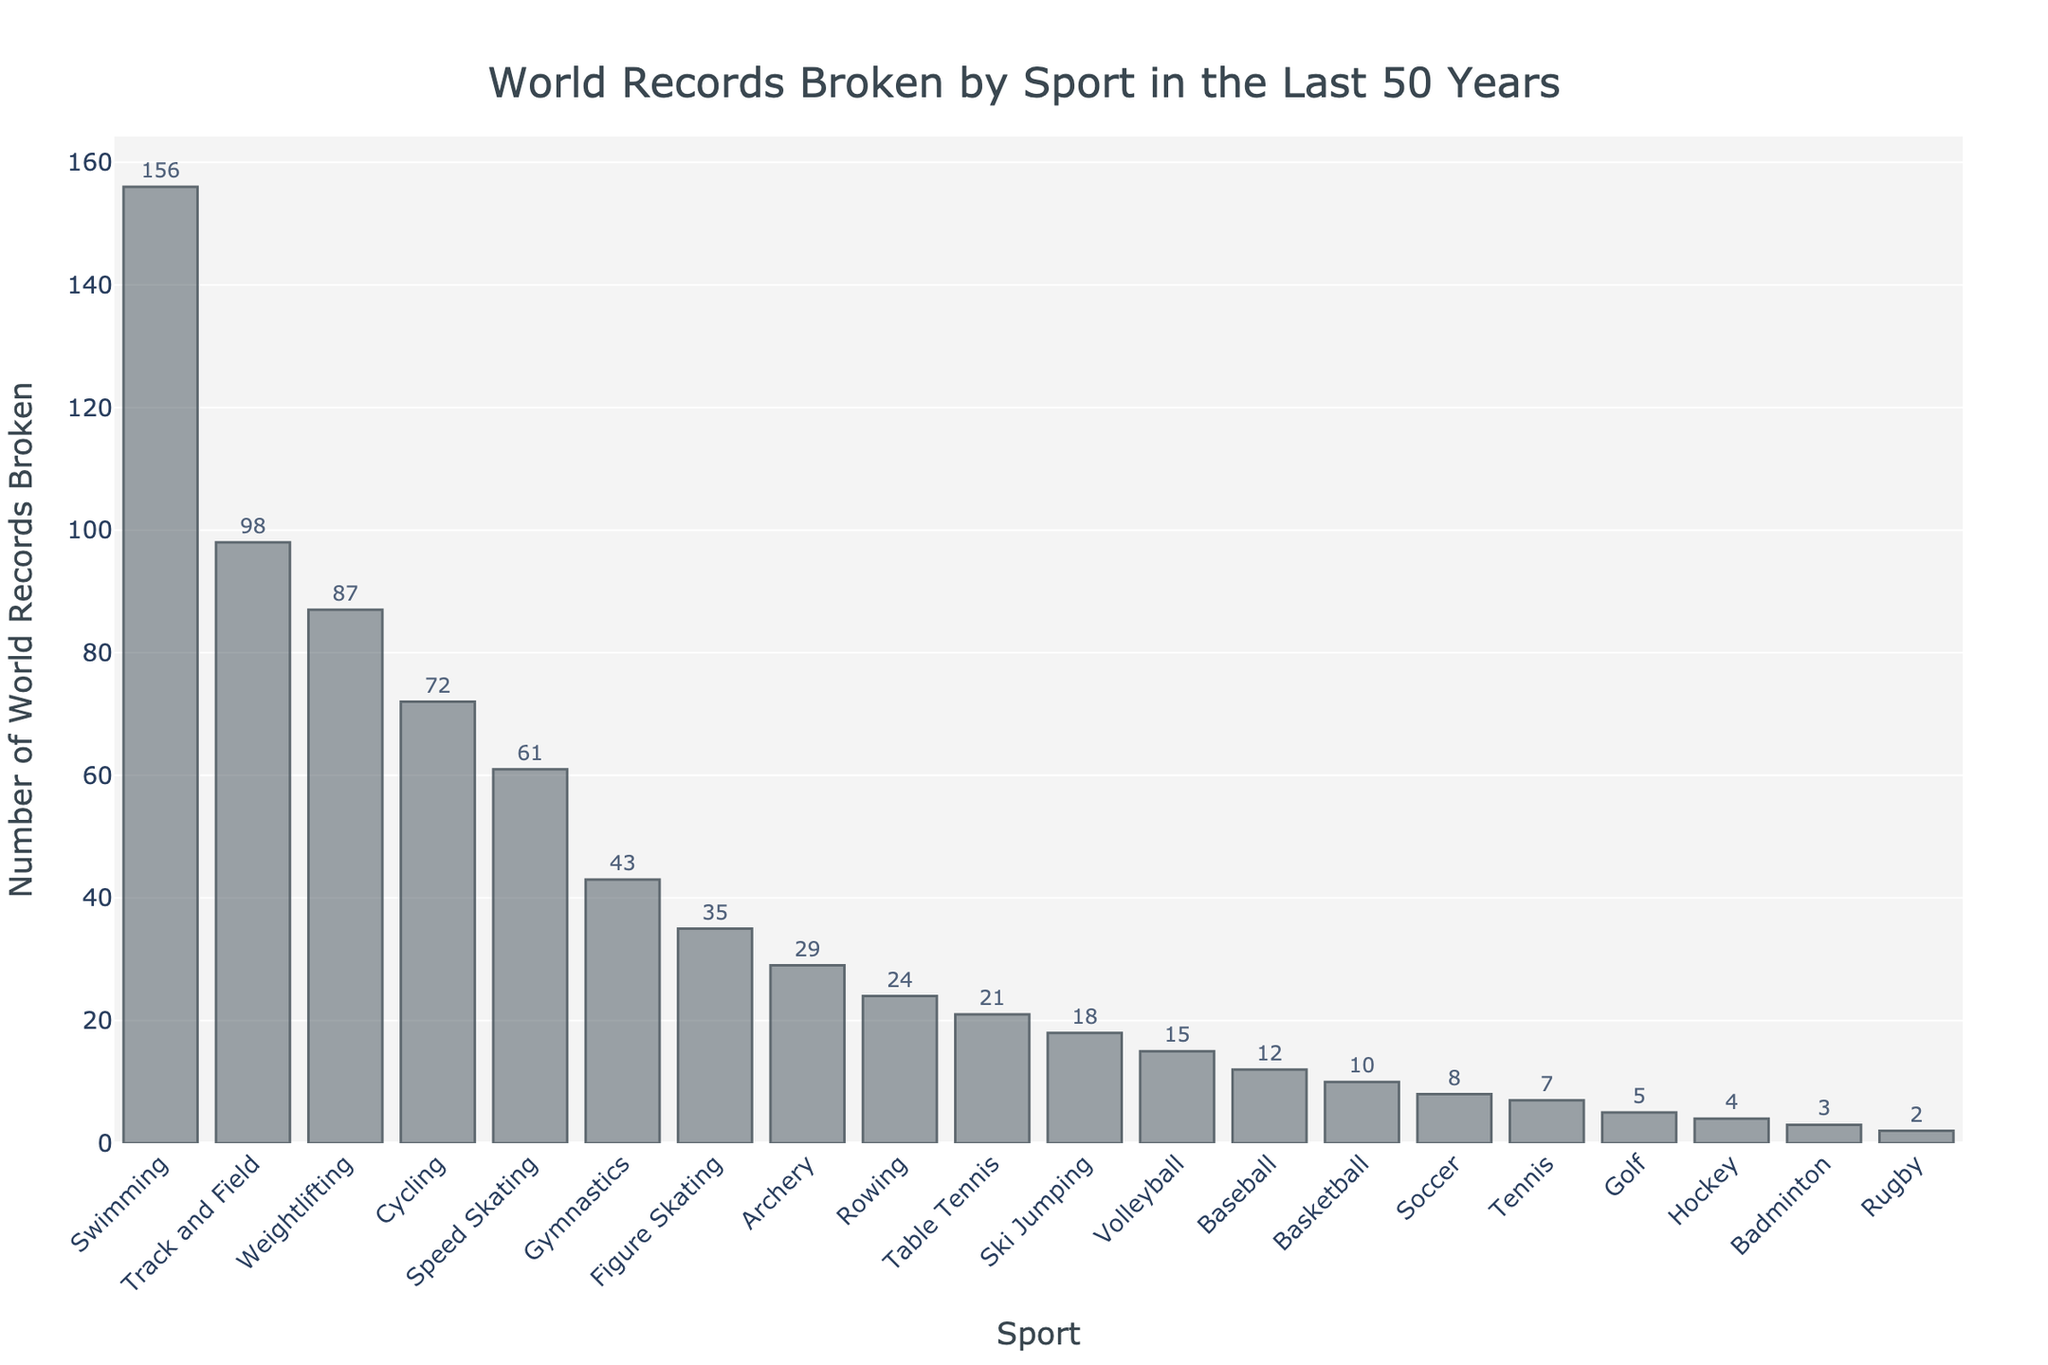What sport has the highest number of world records broken? The sport with the highest number of world records broken is the one with the tallest bar. By looking at the chart, that sport is Swimming.
Answer: Swimming Which sport has twice as many world records broken as weightlifting? Swimming has 156 world records broken, and Weightlifting has 87. If you compare other sports, none of them have exactly twice the number of world records as Weightlifting (174).
Answer: None What is the total number of world records broken in Swimming, Cycling, and Gymnastics combined? Add the number of world records broken in Swimming (156), Cycling (72), and Gymnastics (43): 156 + 72 + 43 = 271
Answer: 271 How many more world records have been broken in Track and Field compared to Tennis? Subtract the number of world records broken in Tennis (7) from Track and Field (98): 98 - 7 = 91
Answer: 91 Which has more world records broken, Speed Skating or Figure Skating? Compare the heights of the bars for Speed Skating (61) and Figure Skating (35). Speed Skating has more world records broken.
Answer: Speed Skating What is the average number of world records broken for the top 3 sports? The top 3 sports are Swimming (156), Track and Field (98), and Weightlifting (87). The average is calculated as (156 + 98 + 87) / 3 = 341 / 3 ≈ 113.67
Answer: 113.67 How many sports have fewer than 10 world records broken? Count the bars representing the sports with fewer than 10 world records broken: 4 (Soccer with 8, Tennis with 7, Golf with 5, Hockey with 4, Badminton with 3, Rugby with 2).
Answer: 6 What is the difference in the number of world records between Rowing and Table Tennis? Subtract the number of world records broken in Table Tennis (21) from Rowing (24): 24 - 21 = 3
Answer: 3 Which sport's bar is colored differently to indicate the number of world records broken? All bars in the chart have the same color and are visually coded with consistent data representation, so no single sport's bar is colored differently.
Answer: None What is the total number of world records broken by the top 5 sports combined? Sum the number of world records broken by Swimming (156), Track and Field (98), Weightlifting (87), Cycling (72), and Speed Skating (61): 156 + 98 + 87 + 72 + 61 = 474
Answer: 474 